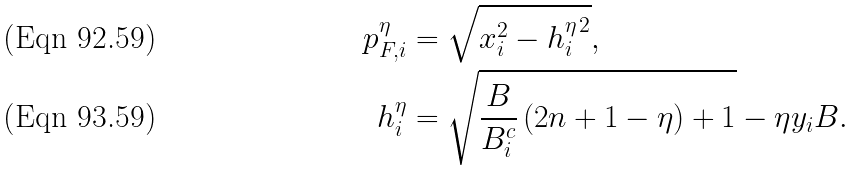Convert formula to latex. <formula><loc_0><loc_0><loc_500><loc_500>p _ { F , i } ^ { \eta } & = \sqrt { x _ { i } ^ { 2 } - h _ { i } ^ { \eta \, 2 } } , \\ h _ { i } ^ { \eta } & = \sqrt { \frac { B } { B ^ { c } _ { i } } \, ( 2 n + 1 - \eta ) + 1 } - \eta y _ { i } B .</formula> 